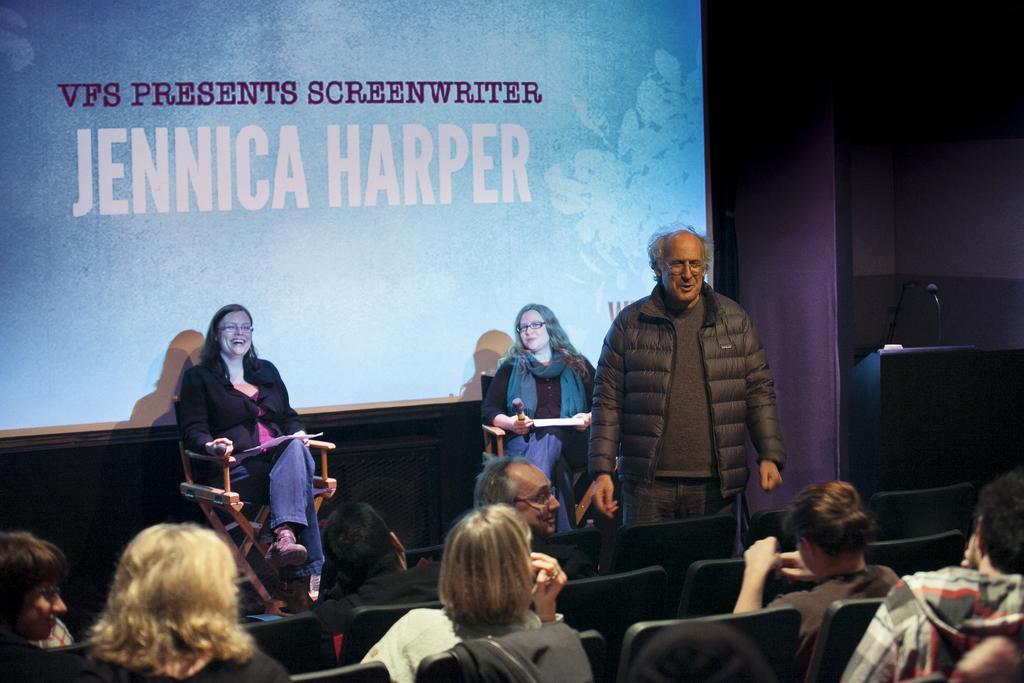How would you summarize this image in a sentence or two? In this image there are people sitting. On the right there is a man standing. In the background there is a screen. The ladies sitting in the center are holding mics and papers. 